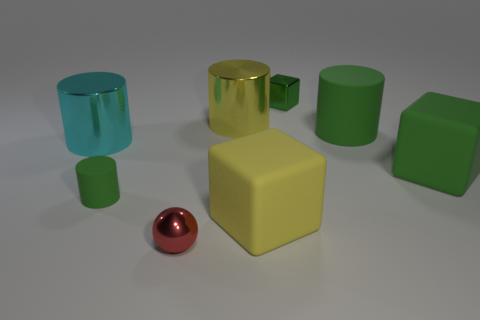Add 2 cylinders. How many objects exist? 10 Subtract all blocks. How many objects are left? 5 Subtract 0 purple cylinders. How many objects are left? 8 Subtract all small blue shiny cylinders. Subtract all tiny green things. How many objects are left? 6 Add 3 small green metal objects. How many small green metal objects are left? 4 Add 7 big shiny cylinders. How many big shiny cylinders exist? 9 